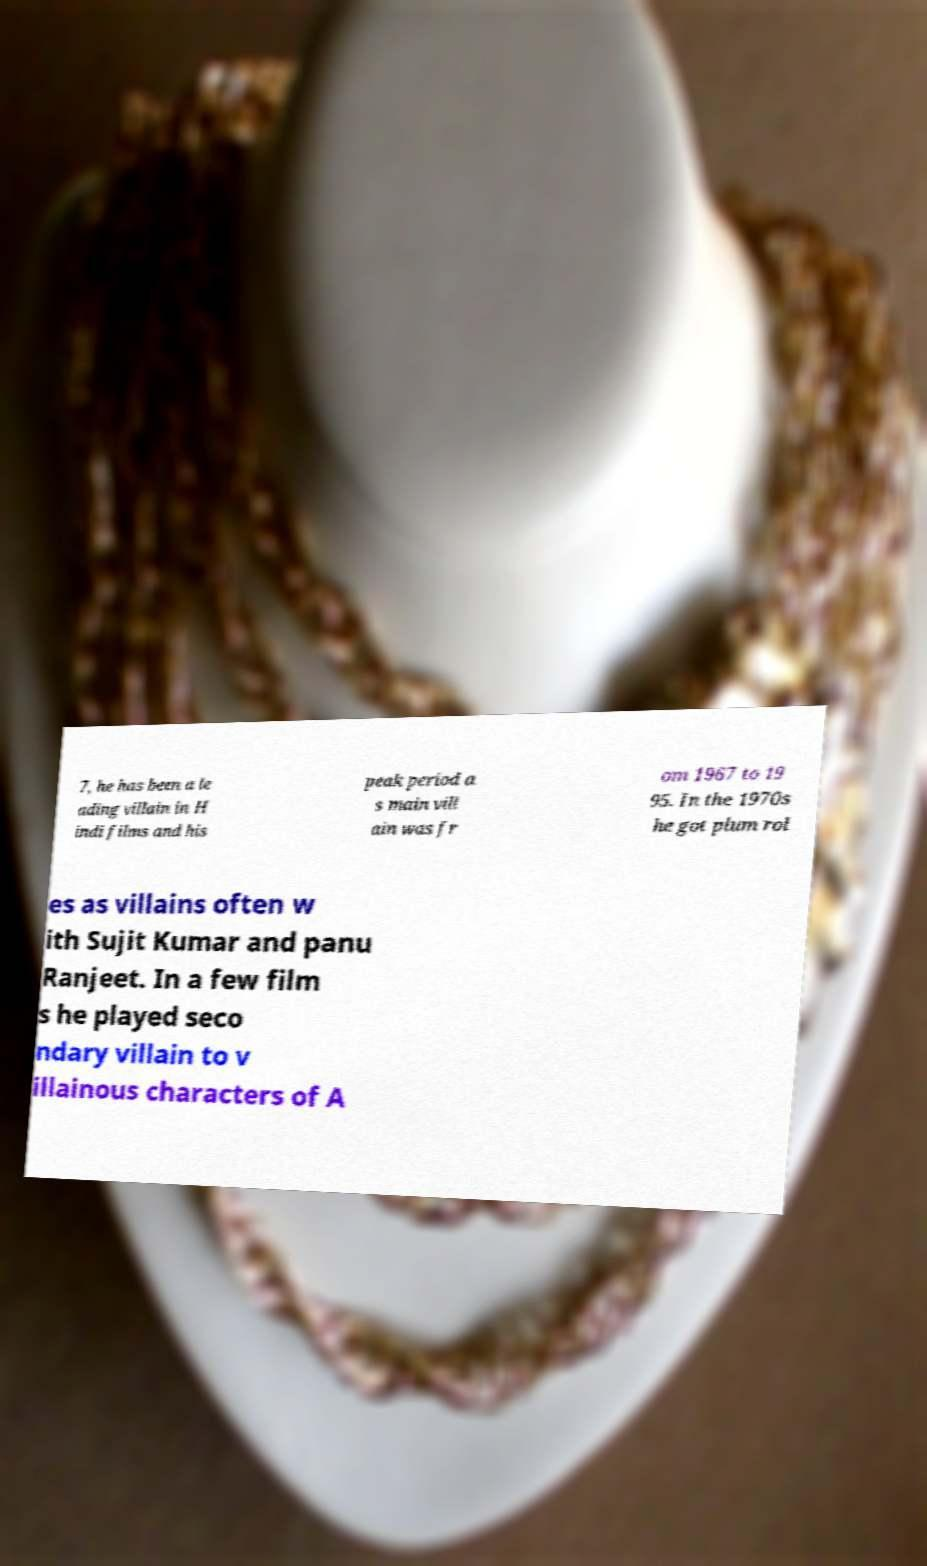What messages or text are displayed in this image? I need them in a readable, typed format. 7, he has been a le ading villain in H indi films and his peak period a s main vill ain was fr om 1967 to 19 95. In the 1970s he got plum rol es as villains often w ith Sujit Kumar and panu Ranjeet. In a few film s he played seco ndary villain to v illainous characters of A 